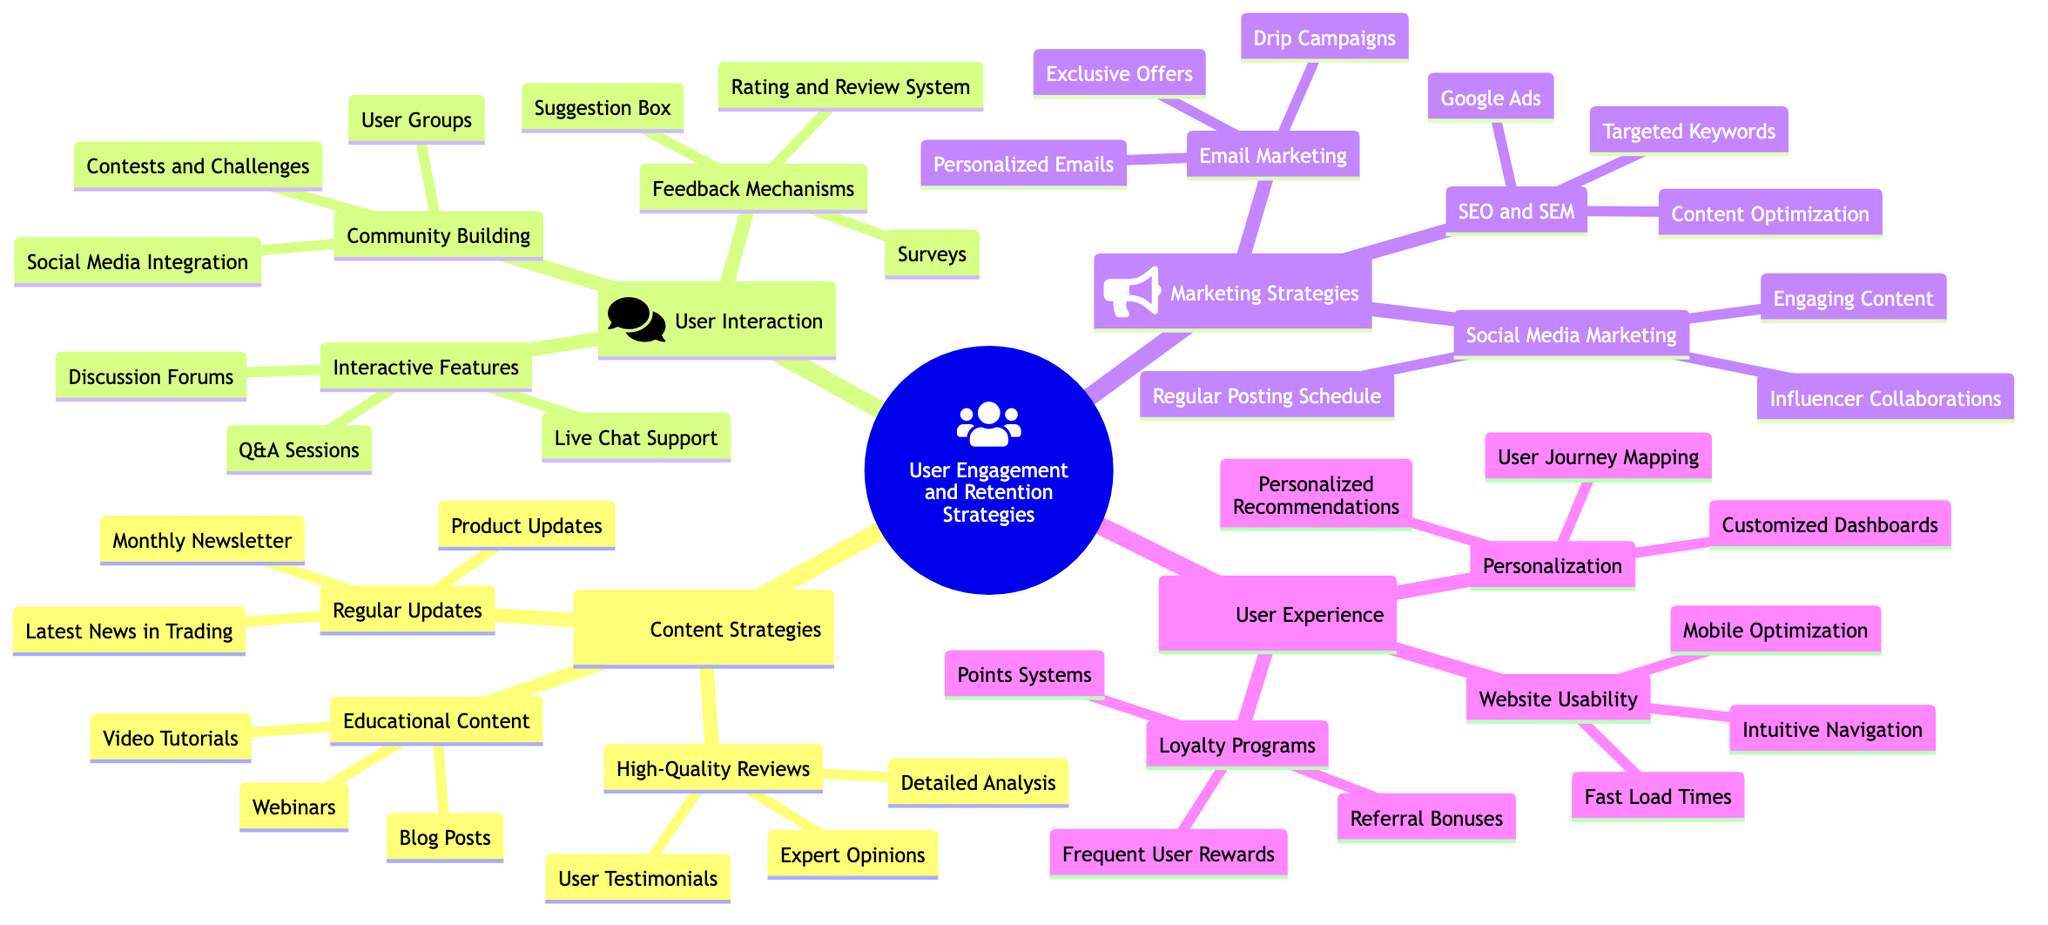What are the three categories of strategies outlined in the diagram? The diagram shows four main categories at the root level: Content Strategies, User Interaction, Marketing Strategies, and User Experience.
Answer: Content Strategies, User Interaction, Marketing Strategies, User Experience How many nodes are under "Content Strategies"? Under "Content Strategies," there are three nodes: High-Quality Reviews, Educational Content, and Regular Updates.
Answer: 3 What is one example of an interactive feature listed in the diagram? The diagram lists Discussion Forums, Live Chat Support, and Q&A Sessions as examples of interactive features. One example is Discussion Forums.
Answer: Discussion Forums Which marketing strategy includes "Personalized Emails"? Personalized Emails are part of the Email Marketing strategy, as categorized under Marketing Strategies.
Answer: Email Marketing What do the "Loyalty Programs" focus on in the context of user experience? The Loyalty Programs category includes Points Systems, Frequent User Rewards, and Referral Bonuses, focusing on incentivizing users to stay engaged.
Answer: Points Systems, Frequent User Rewards, Referral Bonuses Which category has the highest number of sub-nodes? User Interaction has the highest number of sub-nodes with three main categories, each with three sub-nodes, totaling nine sub-nodes.
Answer: 9 What relationship exists between "Community Building" and "Feedback Mechanisms"? Both "Community Building" and "Feedback Mechanisms" are sub-categories under the broader category of User Interaction, indicating they are part of the same overarching strategy.
Answer: Same category Which element emphasizes fast user experience? Under User Experience, the element focusing on fast user experience is Fast Load Times.
Answer: Fast Load Times How are "Expert Opinions" categorized in the diagram? Expert Opinions are categorized under High-Quality Reviews, which is the first branch of Content Strategies.
Answer: High-Quality Reviews 